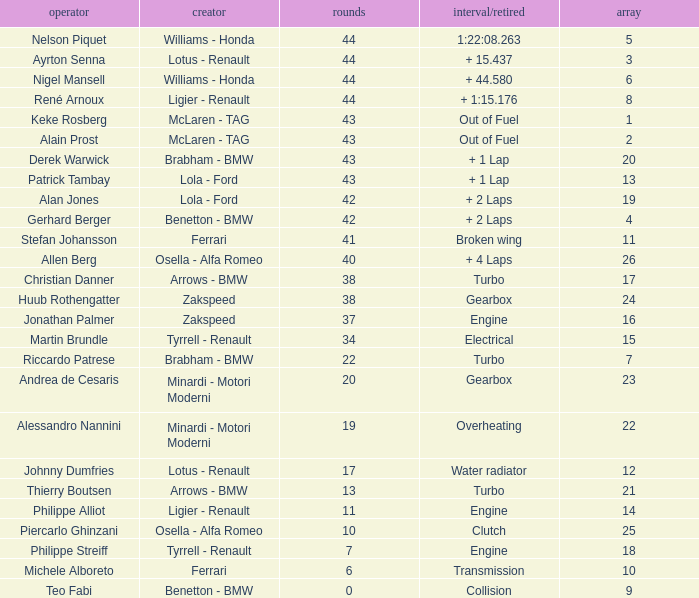I want the driver that has Laps of 10 Piercarlo Ghinzani. 